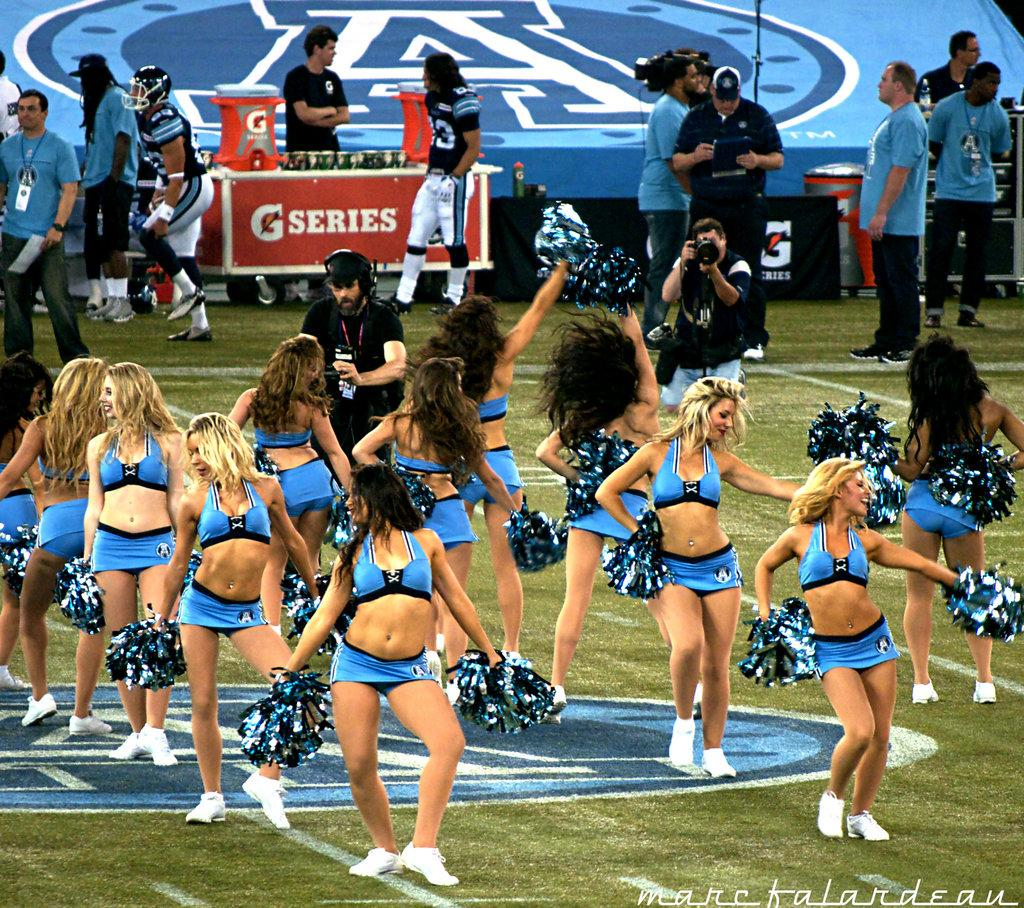What are the girls in the image wearing? The girls in the image are wearing bikinis. What are the girls doing in the image? The girls are dancing on the grass land. What might the girls be associated with, based on their appearance? The girls appear to be cheer girls. What are some men in the image doing? Some men in the image are holding cameras. What is the activity of other men in the image? Some men are walking in the image. What type of waves can be seen crashing on the shore in the image? There is no shore or waves present in the image; it features girls in bikinis dancing on grass land and men holding cameras or walking. 